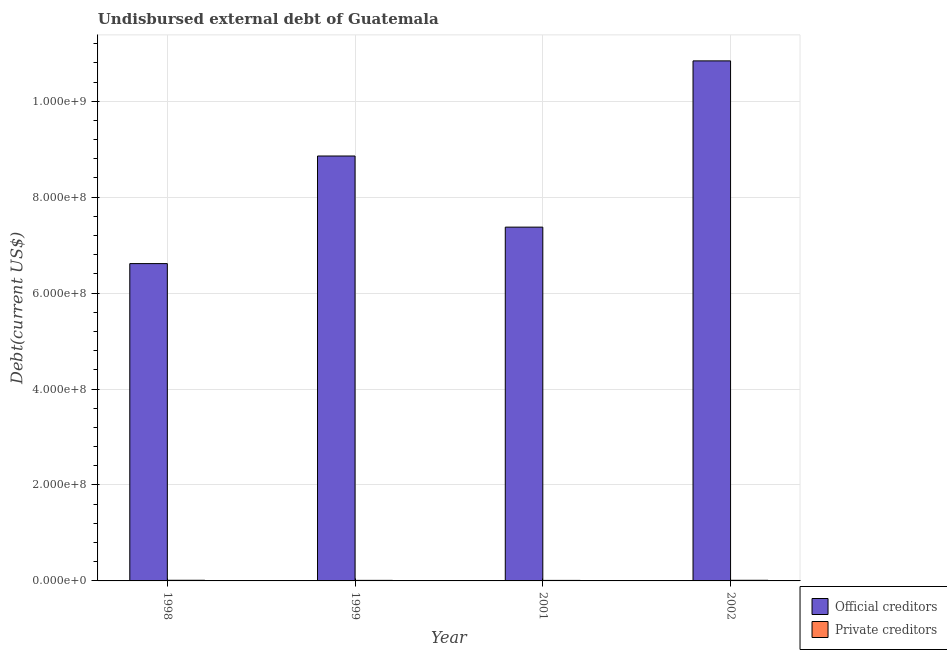How many different coloured bars are there?
Your answer should be compact. 2. Are the number of bars per tick equal to the number of legend labels?
Keep it short and to the point. Yes. Are the number of bars on each tick of the X-axis equal?
Ensure brevity in your answer.  Yes. How many bars are there on the 3rd tick from the left?
Give a very brief answer. 2. In how many cases, is the number of bars for a given year not equal to the number of legend labels?
Make the answer very short. 0. What is the undisbursed external debt of private creditors in 2002?
Keep it short and to the point. 1.30e+06. Across all years, what is the maximum undisbursed external debt of private creditors?
Your answer should be very brief. 1.36e+06. Across all years, what is the minimum undisbursed external debt of private creditors?
Your answer should be very brief. 1.08e+06. In which year was the undisbursed external debt of official creditors maximum?
Offer a very short reply. 2002. In which year was the undisbursed external debt of official creditors minimum?
Your answer should be compact. 1998. What is the total undisbursed external debt of private creditors in the graph?
Offer a terse response. 4.90e+06. What is the difference between the undisbursed external debt of private creditors in 1998 and that in 2001?
Provide a succinct answer. 2.78e+05. What is the difference between the undisbursed external debt of official creditors in 1998 and the undisbursed external debt of private creditors in 2002?
Your response must be concise. -4.23e+08. What is the average undisbursed external debt of private creditors per year?
Keep it short and to the point. 1.23e+06. In the year 1999, what is the difference between the undisbursed external debt of official creditors and undisbursed external debt of private creditors?
Your answer should be very brief. 0. In how many years, is the undisbursed external debt of official creditors greater than 160000000 US$?
Offer a terse response. 4. What is the ratio of the undisbursed external debt of private creditors in 1999 to that in 2002?
Your answer should be very brief. 0.89. Is the undisbursed external debt of official creditors in 1999 less than that in 2001?
Provide a short and direct response. No. What is the difference between the highest and the second highest undisbursed external debt of private creditors?
Give a very brief answer. 5.20e+04. What is the difference between the highest and the lowest undisbursed external debt of official creditors?
Provide a succinct answer. 4.23e+08. Is the sum of the undisbursed external debt of private creditors in 1998 and 2001 greater than the maximum undisbursed external debt of official creditors across all years?
Make the answer very short. Yes. What does the 2nd bar from the left in 1998 represents?
Your answer should be very brief. Private creditors. What does the 2nd bar from the right in 2001 represents?
Make the answer very short. Official creditors. How many bars are there?
Give a very brief answer. 8. How many years are there in the graph?
Keep it short and to the point. 4. What is the difference between two consecutive major ticks on the Y-axis?
Make the answer very short. 2.00e+08. Does the graph contain any zero values?
Your answer should be compact. No. Does the graph contain grids?
Ensure brevity in your answer.  Yes. How many legend labels are there?
Offer a very short reply. 2. What is the title of the graph?
Make the answer very short. Undisbursed external debt of Guatemala. Does "Male" appear as one of the legend labels in the graph?
Give a very brief answer. No. What is the label or title of the Y-axis?
Make the answer very short. Debt(current US$). What is the Debt(current US$) of Official creditors in 1998?
Ensure brevity in your answer.  6.62e+08. What is the Debt(current US$) of Private creditors in 1998?
Ensure brevity in your answer.  1.36e+06. What is the Debt(current US$) of Official creditors in 1999?
Offer a very short reply. 8.86e+08. What is the Debt(current US$) in Private creditors in 1999?
Offer a terse response. 1.17e+06. What is the Debt(current US$) in Official creditors in 2001?
Your answer should be compact. 7.38e+08. What is the Debt(current US$) in Private creditors in 2001?
Offer a terse response. 1.08e+06. What is the Debt(current US$) in Official creditors in 2002?
Provide a short and direct response. 1.08e+09. What is the Debt(current US$) in Private creditors in 2002?
Offer a very short reply. 1.30e+06. Across all years, what is the maximum Debt(current US$) in Official creditors?
Your answer should be compact. 1.08e+09. Across all years, what is the maximum Debt(current US$) in Private creditors?
Offer a very short reply. 1.36e+06. Across all years, what is the minimum Debt(current US$) of Official creditors?
Keep it short and to the point. 6.62e+08. Across all years, what is the minimum Debt(current US$) in Private creditors?
Your response must be concise. 1.08e+06. What is the total Debt(current US$) of Official creditors in the graph?
Your answer should be compact. 3.37e+09. What is the total Debt(current US$) of Private creditors in the graph?
Offer a terse response. 4.90e+06. What is the difference between the Debt(current US$) in Official creditors in 1998 and that in 1999?
Your answer should be very brief. -2.24e+08. What is the difference between the Debt(current US$) of Private creditors in 1998 and that in 1999?
Provide a succinct answer. 1.89e+05. What is the difference between the Debt(current US$) in Official creditors in 1998 and that in 2001?
Ensure brevity in your answer.  -7.60e+07. What is the difference between the Debt(current US$) in Private creditors in 1998 and that in 2001?
Your response must be concise. 2.78e+05. What is the difference between the Debt(current US$) in Official creditors in 1998 and that in 2002?
Make the answer very short. -4.23e+08. What is the difference between the Debt(current US$) in Private creditors in 1998 and that in 2002?
Your response must be concise. 5.20e+04. What is the difference between the Debt(current US$) in Official creditors in 1999 and that in 2001?
Your answer should be very brief. 1.48e+08. What is the difference between the Debt(current US$) in Private creditors in 1999 and that in 2001?
Give a very brief answer. 8.90e+04. What is the difference between the Debt(current US$) of Official creditors in 1999 and that in 2002?
Offer a very short reply. -1.98e+08. What is the difference between the Debt(current US$) of Private creditors in 1999 and that in 2002?
Ensure brevity in your answer.  -1.37e+05. What is the difference between the Debt(current US$) of Official creditors in 2001 and that in 2002?
Your answer should be compact. -3.47e+08. What is the difference between the Debt(current US$) in Private creditors in 2001 and that in 2002?
Your answer should be compact. -2.26e+05. What is the difference between the Debt(current US$) of Official creditors in 1998 and the Debt(current US$) of Private creditors in 1999?
Provide a short and direct response. 6.60e+08. What is the difference between the Debt(current US$) in Official creditors in 1998 and the Debt(current US$) in Private creditors in 2001?
Make the answer very short. 6.60e+08. What is the difference between the Debt(current US$) in Official creditors in 1998 and the Debt(current US$) in Private creditors in 2002?
Your answer should be very brief. 6.60e+08. What is the difference between the Debt(current US$) in Official creditors in 1999 and the Debt(current US$) in Private creditors in 2001?
Keep it short and to the point. 8.85e+08. What is the difference between the Debt(current US$) of Official creditors in 1999 and the Debt(current US$) of Private creditors in 2002?
Your answer should be compact. 8.84e+08. What is the difference between the Debt(current US$) of Official creditors in 2001 and the Debt(current US$) of Private creditors in 2002?
Your answer should be compact. 7.36e+08. What is the average Debt(current US$) in Official creditors per year?
Your answer should be compact. 8.42e+08. What is the average Debt(current US$) of Private creditors per year?
Offer a terse response. 1.23e+06. In the year 1998, what is the difference between the Debt(current US$) of Official creditors and Debt(current US$) of Private creditors?
Offer a terse response. 6.60e+08. In the year 1999, what is the difference between the Debt(current US$) in Official creditors and Debt(current US$) in Private creditors?
Offer a very short reply. 8.85e+08. In the year 2001, what is the difference between the Debt(current US$) in Official creditors and Debt(current US$) in Private creditors?
Your answer should be very brief. 7.36e+08. In the year 2002, what is the difference between the Debt(current US$) of Official creditors and Debt(current US$) of Private creditors?
Provide a succinct answer. 1.08e+09. What is the ratio of the Debt(current US$) in Official creditors in 1998 to that in 1999?
Offer a terse response. 0.75. What is the ratio of the Debt(current US$) in Private creditors in 1998 to that in 1999?
Your response must be concise. 1.16. What is the ratio of the Debt(current US$) of Official creditors in 1998 to that in 2001?
Ensure brevity in your answer.  0.9. What is the ratio of the Debt(current US$) of Private creditors in 1998 to that in 2001?
Your answer should be compact. 1.26. What is the ratio of the Debt(current US$) of Official creditors in 1998 to that in 2002?
Offer a very short reply. 0.61. What is the ratio of the Debt(current US$) of Private creditors in 1998 to that in 2002?
Ensure brevity in your answer.  1.04. What is the ratio of the Debt(current US$) of Official creditors in 1999 to that in 2001?
Ensure brevity in your answer.  1.2. What is the ratio of the Debt(current US$) in Private creditors in 1999 to that in 2001?
Provide a succinct answer. 1.08. What is the ratio of the Debt(current US$) in Official creditors in 1999 to that in 2002?
Your answer should be very brief. 0.82. What is the ratio of the Debt(current US$) of Private creditors in 1999 to that in 2002?
Give a very brief answer. 0.89. What is the ratio of the Debt(current US$) of Official creditors in 2001 to that in 2002?
Keep it short and to the point. 0.68. What is the ratio of the Debt(current US$) of Private creditors in 2001 to that in 2002?
Provide a short and direct response. 0.83. What is the difference between the highest and the second highest Debt(current US$) in Official creditors?
Your response must be concise. 1.98e+08. What is the difference between the highest and the second highest Debt(current US$) in Private creditors?
Your answer should be very brief. 5.20e+04. What is the difference between the highest and the lowest Debt(current US$) in Official creditors?
Ensure brevity in your answer.  4.23e+08. What is the difference between the highest and the lowest Debt(current US$) in Private creditors?
Your response must be concise. 2.78e+05. 